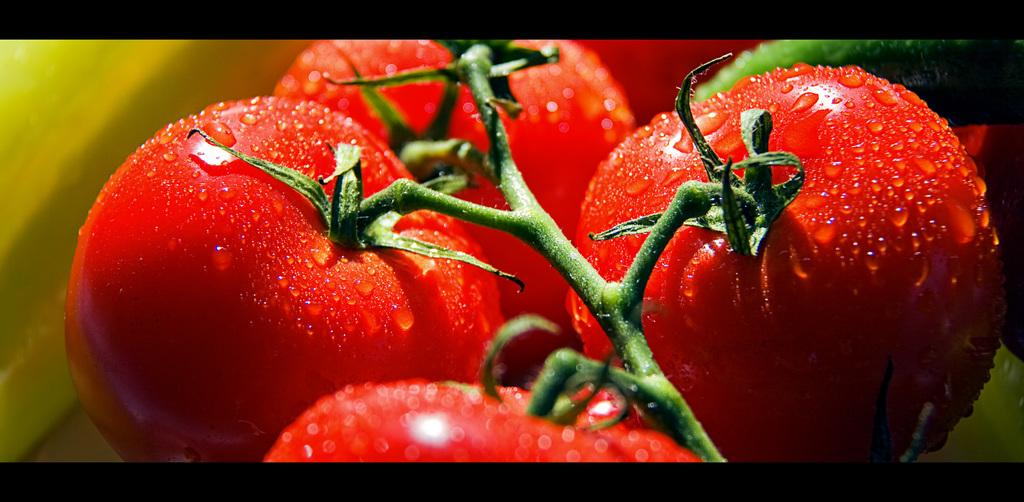What type of plant is visible in the foreground of the image? There are four tomatoes on a stem in the foreground of the image. What colors can be seen in the background of the image? There are green and yellow color objects in the background of the image. How are the borders of the image designed? There are black borders at the top and bottom of the image. Can you tell me how many parents are present at the party in the image? There is no party or parents present in the image; it features tomatoes on a stem and background colors. Is there a quill visible in the image? There is no quill present in the image. 